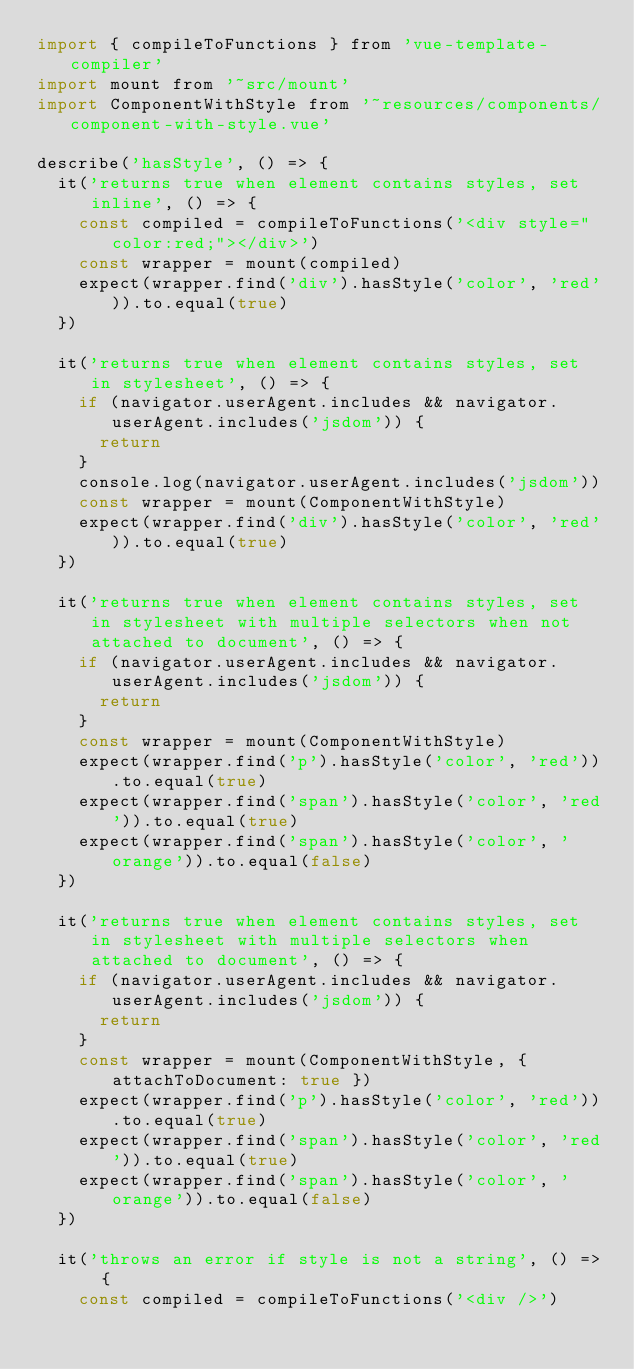<code> <loc_0><loc_0><loc_500><loc_500><_JavaScript_>import { compileToFunctions } from 'vue-template-compiler'
import mount from '~src/mount'
import ComponentWithStyle from '~resources/components/component-with-style.vue'

describe('hasStyle', () => {
  it('returns true when element contains styles, set inline', () => {
    const compiled = compileToFunctions('<div style="color:red;"></div>')
    const wrapper = mount(compiled)
    expect(wrapper.find('div').hasStyle('color', 'red')).to.equal(true)
  })

  it('returns true when element contains styles, set in stylesheet', () => {
    if (navigator.userAgent.includes && navigator.userAgent.includes('jsdom')) {
      return
    }
    console.log(navigator.userAgent.includes('jsdom'))
    const wrapper = mount(ComponentWithStyle)
    expect(wrapper.find('div').hasStyle('color', 'red')).to.equal(true)
  })

  it('returns true when element contains styles, set in stylesheet with multiple selectors when not attached to document', () => {
    if (navigator.userAgent.includes && navigator.userAgent.includes('jsdom')) {
      return
    }
    const wrapper = mount(ComponentWithStyle)
    expect(wrapper.find('p').hasStyle('color', 'red')).to.equal(true)
    expect(wrapper.find('span').hasStyle('color', 'red')).to.equal(true)
    expect(wrapper.find('span').hasStyle('color', 'orange')).to.equal(false)
  })

  it('returns true when element contains styles, set in stylesheet with multiple selectors when attached to document', () => {
    if (navigator.userAgent.includes && navigator.userAgent.includes('jsdom')) {
      return
    }
    const wrapper = mount(ComponentWithStyle, { attachToDocument: true })
    expect(wrapper.find('p').hasStyle('color', 'red')).to.equal(true)
    expect(wrapper.find('span').hasStyle('color', 'red')).to.equal(true)
    expect(wrapper.find('span').hasStyle('color', 'orange')).to.equal(false)
  })

  it('throws an error if style is not a string', () => {
    const compiled = compileToFunctions('<div />')</code> 